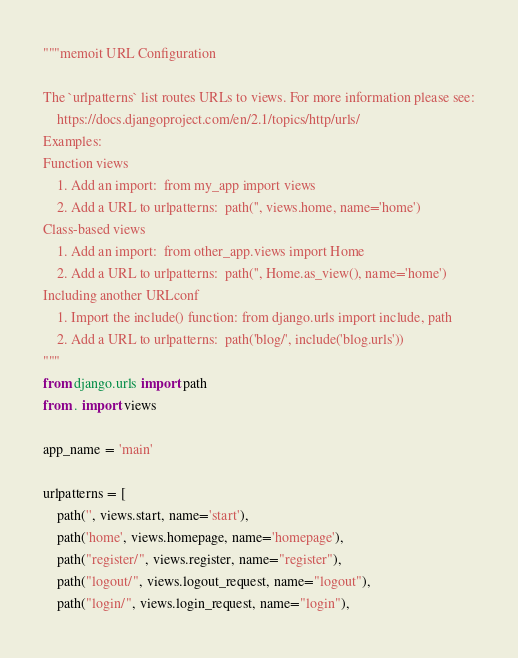<code> <loc_0><loc_0><loc_500><loc_500><_Python_>"""memoit URL Configuration

The `urlpatterns` list routes URLs to views. For more information please see:
    https://docs.djangoproject.com/en/2.1/topics/http/urls/
Examples:
Function views
    1. Add an import:  from my_app import views
    2. Add a URL to urlpatterns:  path('', views.home, name='home')
Class-based views
    1. Add an import:  from other_app.views import Home
    2. Add a URL to urlpatterns:  path('', Home.as_view(), name='home')
Including another URLconf
    1. Import the include() function: from django.urls import include, path
    2. Add a URL to urlpatterns:  path('blog/', include('blog.urls'))
"""
from django.urls import path
from . import views

app_name = 'main'

urlpatterns = [
    path('', views.start, name='start'),
    path('home', views.homepage, name='homepage'),
    path("register/", views.register, name="register"),
    path("logout/", views.logout_request, name="logout"),
    path("login/", views.login_request, name="login"),</code> 